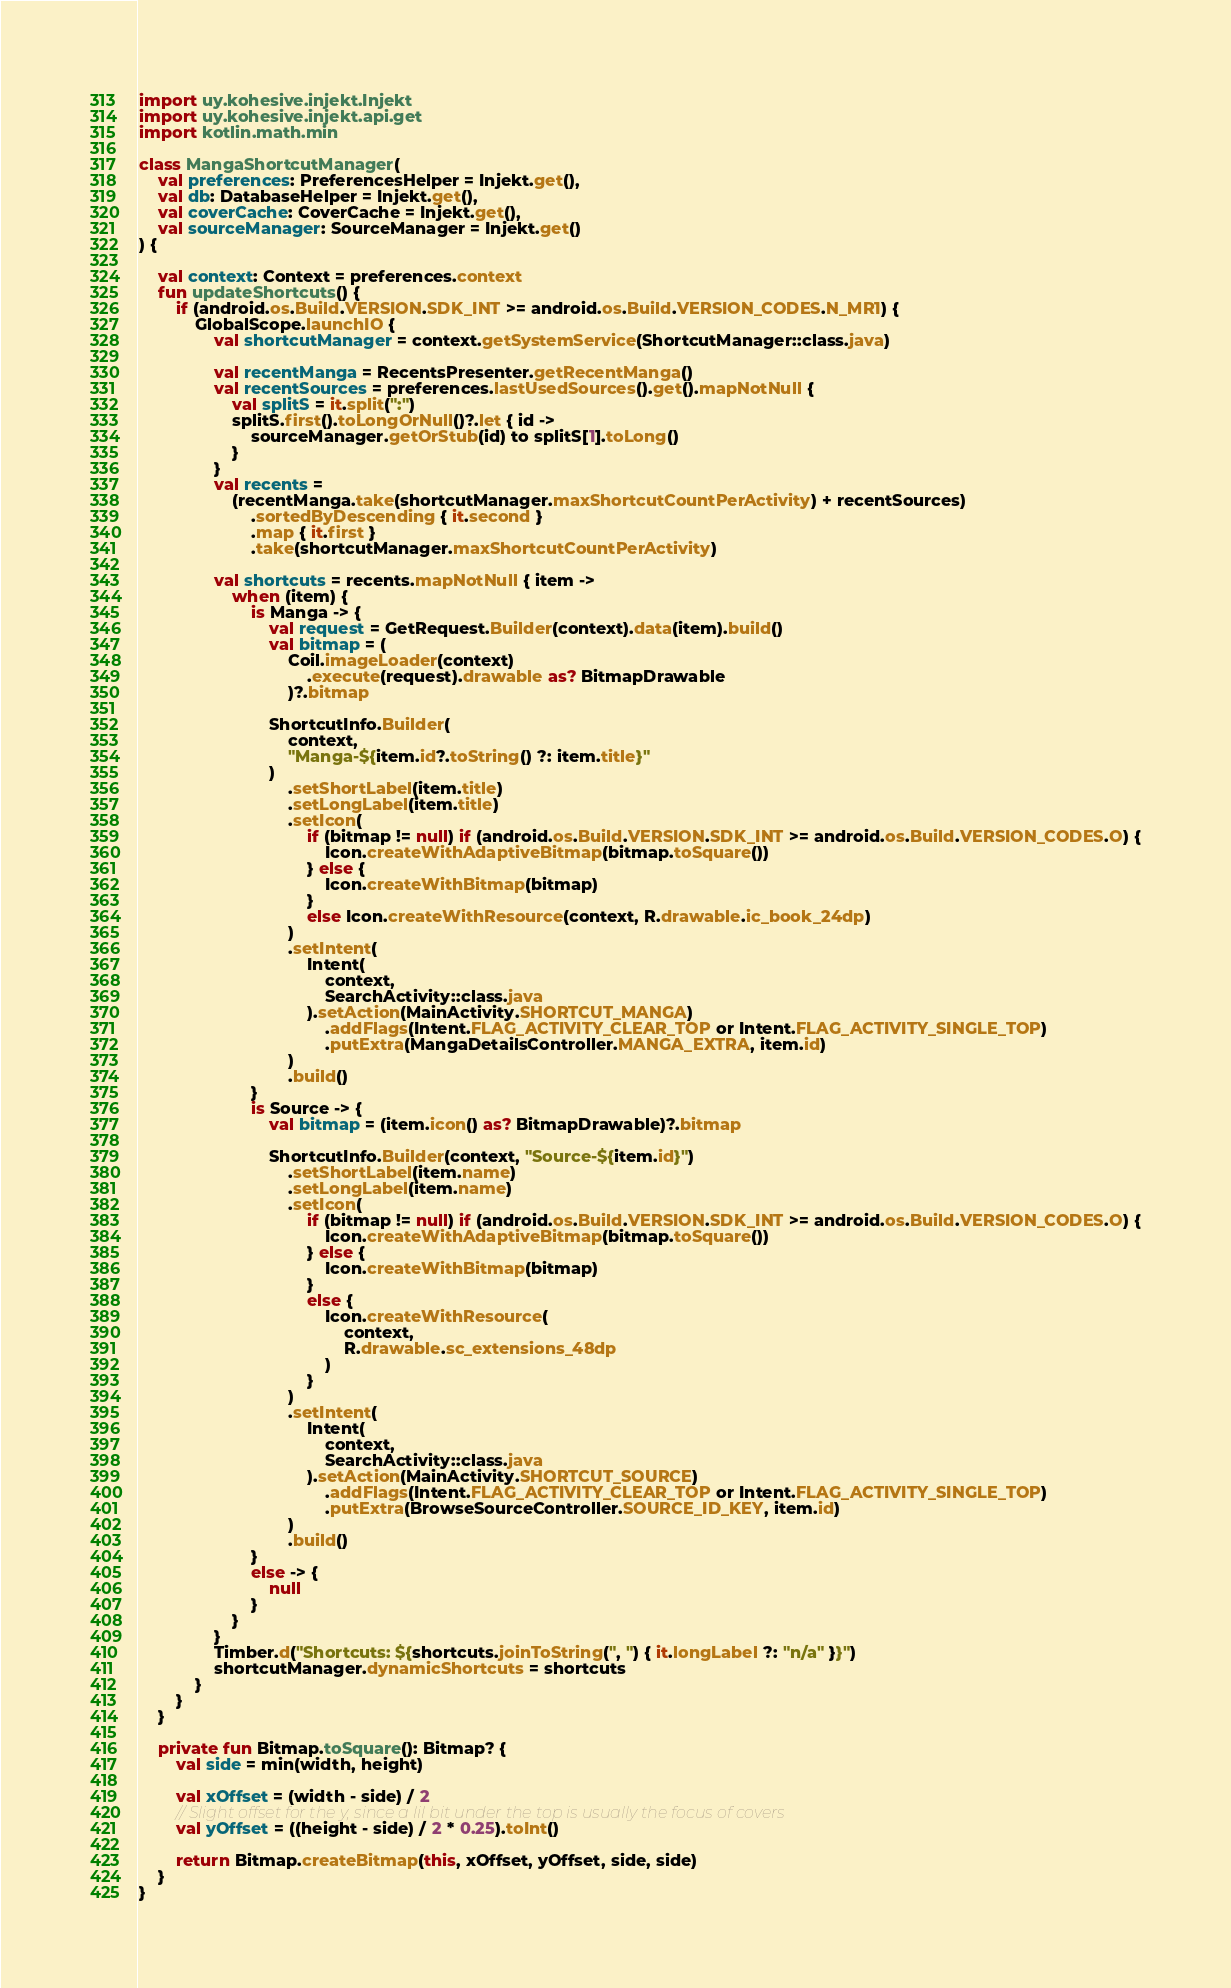Convert code to text. <code><loc_0><loc_0><loc_500><loc_500><_Kotlin_>import uy.kohesive.injekt.Injekt
import uy.kohesive.injekt.api.get
import kotlin.math.min

class MangaShortcutManager(
    val preferences: PreferencesHelper = Injekt.get(),
    val db: DatabaseHelper = Injekt.get(),
    val coverCache: CoverCache = Injekt.get(),
    val sourceManager: SourceManager = Injekt.get()
) {

    val context: Context = preferences.context
    fun updateShortcuts() {
        if (android.os.Build.VERSION.SDK_INT >= android.os.Build.VERSION_CODES.N_MR1) {
            GlobalScope.launchIO {
                val shortcutManager = context.getSystemService(ShortcutManager::class.java)

                val recentManga = RecentsPresenter.getRecentManga()
                val recentSources = preferences.lastUsedSources().get().mapNotNull {
                    val splitS = it.split(":")
                    splitS.first().toLongOrNull()?.let { id ->
                        sourceManager.getOrStub(id) to splitS[1].toLong()
                    }
                }
                val recents =
                    (recentManga.take(shortcutManager.maxShortcutCountPerActivity) + recentSources)
                        .sortedByDescending { it.second }
                        .map { it.first }
                        .take(shortcutManager.maxShortcutCountPerActivity)

                val shortcuts = recents.mapNotNull { item ->
                    when (item) {
                        is Manga -> {
                            val request = GetRequest.Builder(context).data(item).build()
                            val bitmap = (
                                Coil.imageLoader(context)
                                    .execute(request).drawable as? BitmapDrawable
                                )?.bitmap

                            ShortcutInfo.Builder(
                                context,
                                "Manga-${item.id?.toString() ?: item.title}"
                            )
                                .setShortLabel(item.title)
                                .setLongLabel(item.title)
                                .setIcon(
                                    if (bitmap != null) if (android.os.Build.VERSION.SDK_INT >= android.os.Build.VERSION_CODES.O) {
                                        Icon.createWithAdaptiveBitmap(bitmap.toSquare())
                                    } else {
                                        Icon.createWithBitmap(bitmap)
                                    }
                                    else Icon.createWithResource(context, R.drawable.ic_book_24dp)
                                )
                                .setIntent(
                                    Intent(
                                        context,
                                        SearchActivity::class.java
                                    ).setAction(MainActivity.SHORTCUT_MANGA)
                                        .addFlags(Intent.FLAG_ACTIVITY_CLEAR_TOP or Intent.FLAG_ACTIVITY_SINGLE_TOP)
                                        .putExtra(MangaDetailsController.MANGA_EXTRA, item.id)
                                )
                                .build()
                        }
                        is Source -> {
                            val bitmap = (item.icon() as? BitmapDrawable)?.bitmap

                            ShortcutInfo.Builder(context, "Source-${item.id}")
                                .setShortLabel(item.name)
                                .setLongLabel(item.name)
                                .setIcon(
                                    if (bitmap != null) if (android.os.Build.VERSION.SDK_INT >= android.os.Build.VERSION_CODES.O) {
                                        Icon.createWithAdaptiveBitmap(bitmap.toSquare())
                                    } else {
                                        Icon.createWithBitmap(bitmap)
                                    }
                                    else {
                                        Icon.createWithResource(
                                            context,
                                            R.drawable.sc_extensions_48dp
                                        )
                                    }
                                )
                                .setIntent(
                                    Intent(
                                        context,
                                        SearchActivity::class.java
                                    ).setAction(MainActivity.SHORTCUT_SOURCE)
                                        .addFlags(Intent.FLAG_ACTIVITY_CLEAR_TOP or Intent.FLAG_ACTIVITY_SINGLE_TOP)
                                        .putExtra(BrowseSourceController.SOURCE_ID_KEY, item.id)
                                )
                                .build()
                        }
                        else -> {
                            null
                        }
                    }
                }
                Timber.d("Shortcuts: ${shortcuts.joinToString(", ") { it.longLabel ?: "n/a" }}")
                shortcutManager.dynamicShortcuts = shortcuts
            }
        }
    }

    private fun Bitmap.toSquare(): Bitmap? {
        val side = min(width, height)

        val xOffset = (width - side) / 2
        // Slight offset for the y, since a lil bit under the top is usually the focus of covers
        val yOffset = ((height - side) / 2 * 0.25).toInt()

        return Bitmap.createBitmap(this, xOffset, yOffset, side, side)
    }
}
</code> 